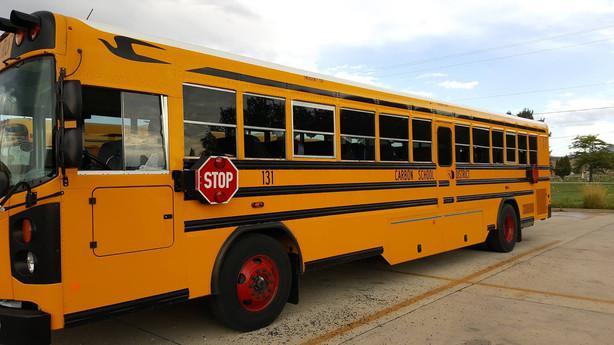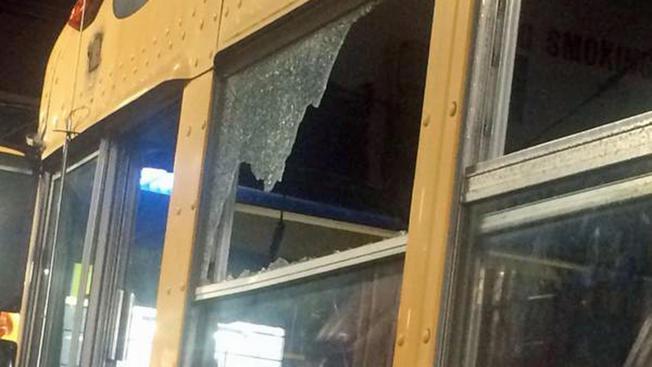The first image is the image on the left, the second image is the image on the right. Examine the images to the left and right. Is the description "A number is printed on the top of the bus in one of the images." accurate? Answer yes or no. No. The first image is the image on the left, the second image is the image on the right. Examine the images to the left and right. Is the description "A school bus seen from above has a white roof with identifying number, and a handicap access door directly behind a passenger door with steps." accurate? Answer yes or no. No. 